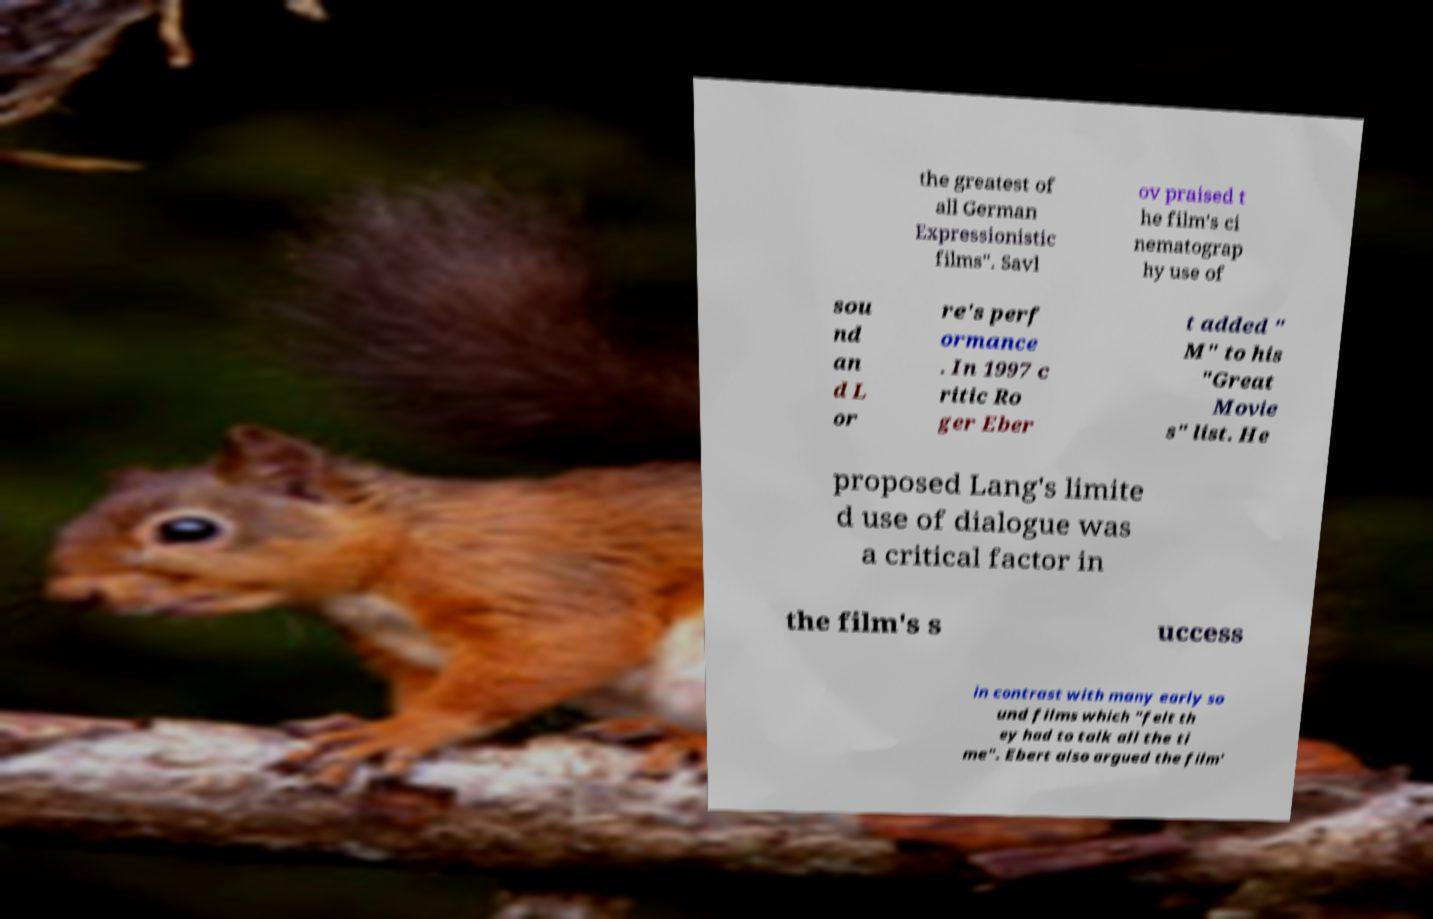What messages or text are displayed in this image? I need them in a readable, typed format. the greatest of all German Expressionistic films". Savl ov praised t he film's ci nematograp hy use of sou nd an d L or re's perf ormance . In 1997 c ritic Ro ger Eber t added " M" to his "Great Movie s" list. He proposed Lang's limite d use of dialogue was a critical factor in the film's s uccess in contrast with many early so und films which "felt th ey had to talk all the ti me". Ebert also argued the film' 